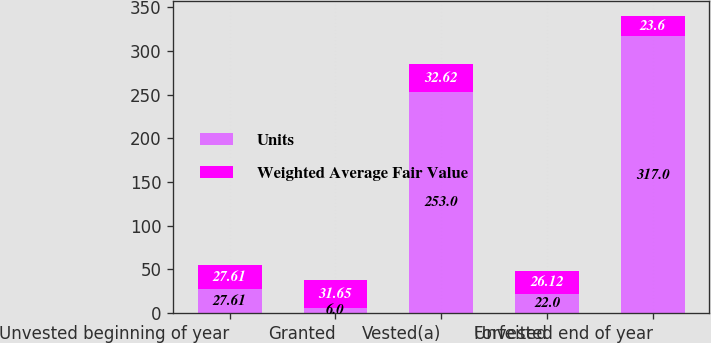Convert chart to OTSL. <chart><loc_0><loc_0><loc_500><loc_500><stacked_bar_chart><ecel><fcel>Unvested beginning of year<fcel>Granted<fcel>Vested(a)<fcel>Forfeited<fcel>Unvested end of year<nl><fcel>Units<fcel>27.61<fcel>6<fcel>253<fcel>22<fcel>317<nl><fcel>Weighted Average Fair Value<fcel>27.61<fcel>31.65<fcel>32.62<fcel>26.12<fcel>23.6<nl></chart> 